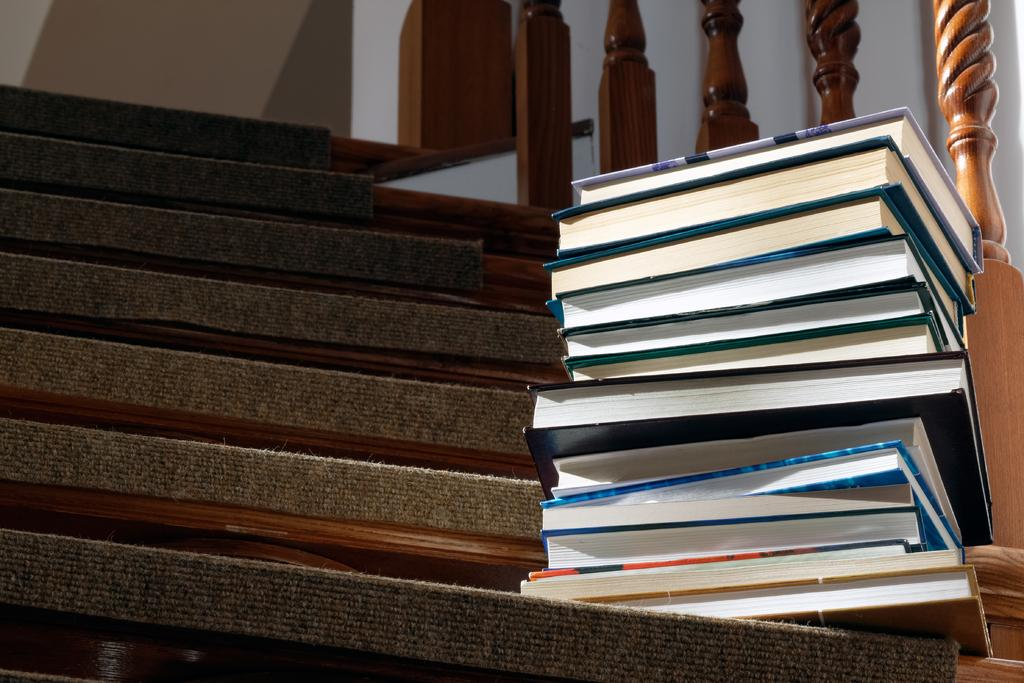What objects are placed on the stairs in the image? There are books on the stairs in the image. What safety feature can be seen in the image? There is a railing visible in the image. What type of structure is present in the image? There is a wall in the image. How does the dock look like in the image? There is no dock present in the image. What is the mind's role in the image? The image does not depict a mind or any mental processes. 